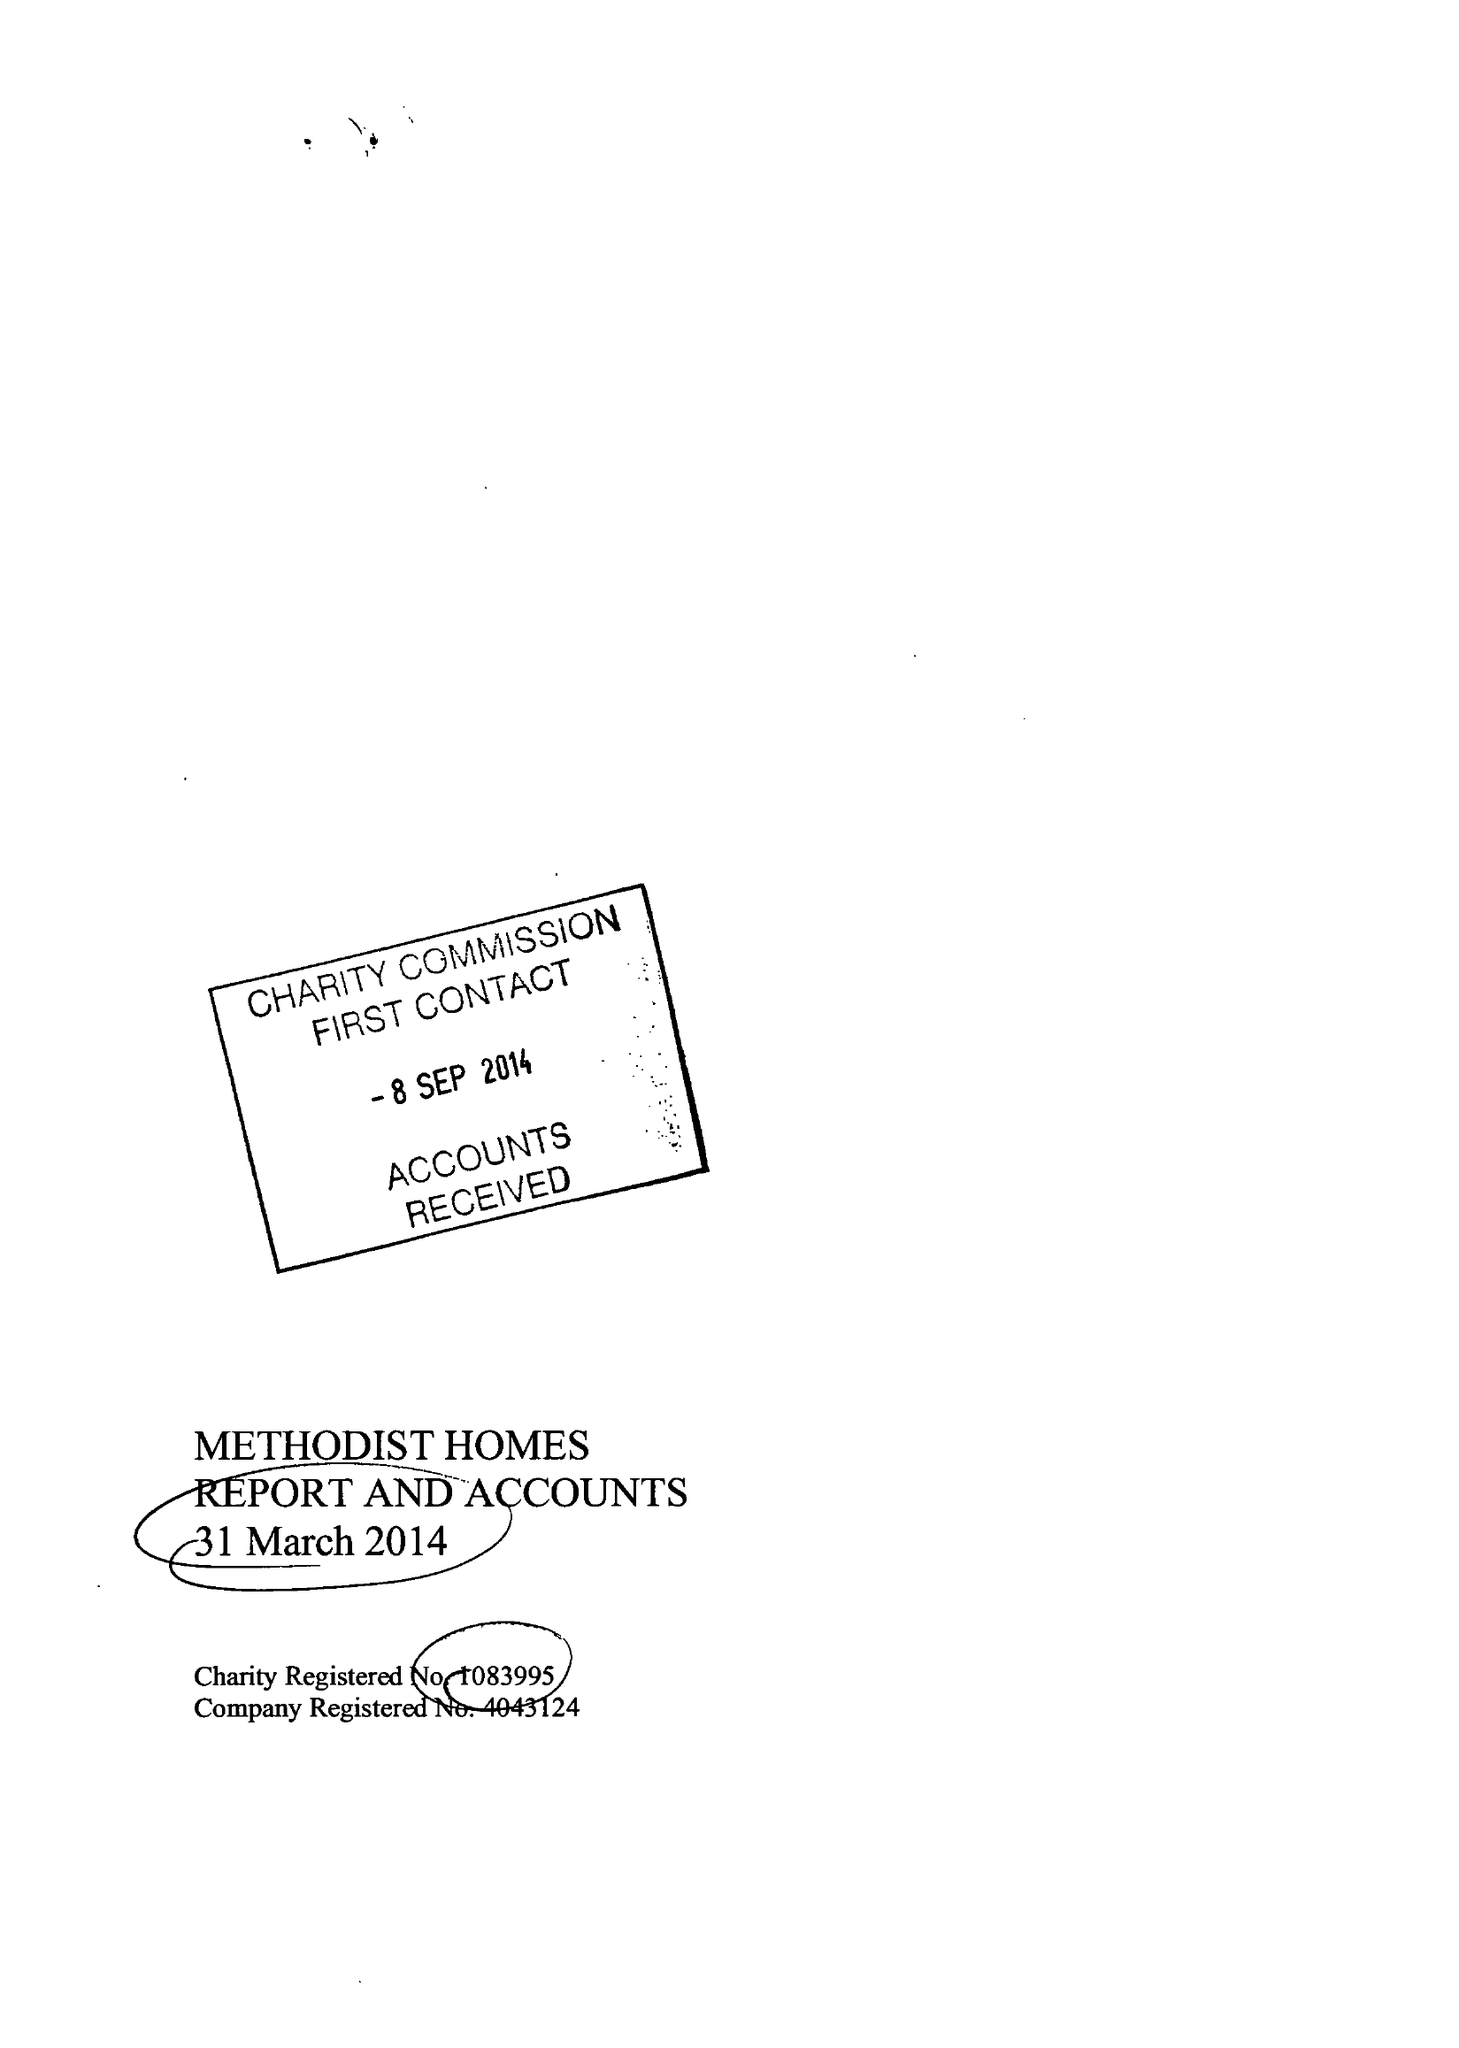What is the value for the charity_name?
Answer the question using a single word or phrase. Methodist Homes 